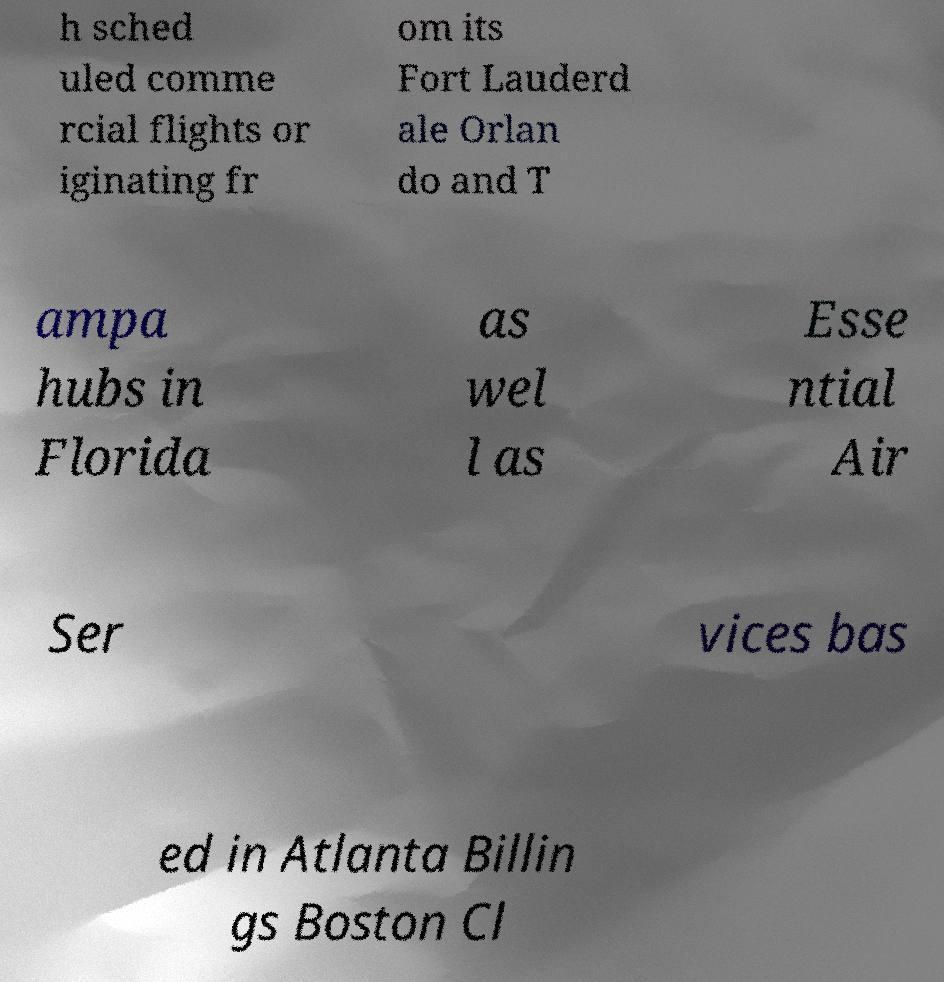I need the written content from this picture converted into text. Can you do that? h sched uled comme rcial flights or iginating fr om its Fort Lauderd ale Orlan do and T ampa hubs in Florida as wel l as Esse ntial Air Ser vices bas ed in Atlanta Billin gs Boston Cl 